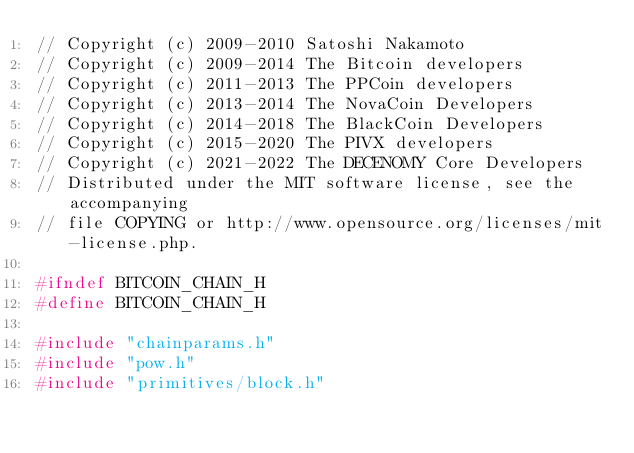Convert code to text. <code><loc_0><loc_0><loc_500><loc_500><_C_>// Copyright (c) 2009-2010 Satoshi Nakamoto
// Copyright (c) 2009-2014 The Bitcoin developers
// Copyright (c) 2011-2013 The PPCoin developers
// Copyright (c) 2013-2014 The NovaCoin Developers
// Copyright (c) 2014-2018 The BlackCoin Developers
// Copyright (c) 2015-2020 The PIVX developers
// Copyright (c) 2021-2022 The DECENOMY Core Developers
// Distributed under the MIT software license, see the accompanying
// file COPYING or http://www.opensource.org/licenses/mit-license.php.

#ifndef BITCOIN_CHAIN_H
#define BITCOIN_CHAIN_H

#include "chainparams.h"
#include "pow.h"
#include "primitives/block.h"</code> 